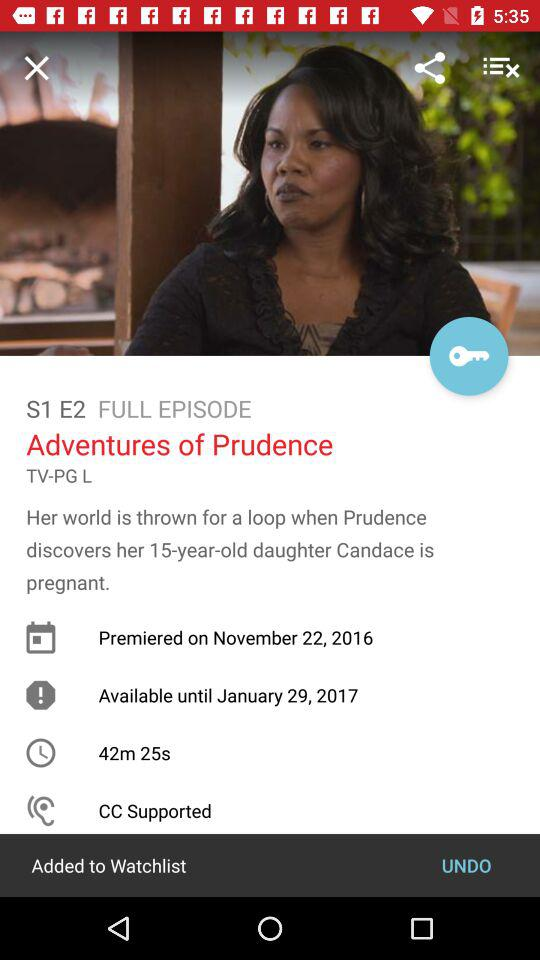When did "Adventures of Prudence" premiere? "Adventures of Prudence" premiered on November 22, 2016. 